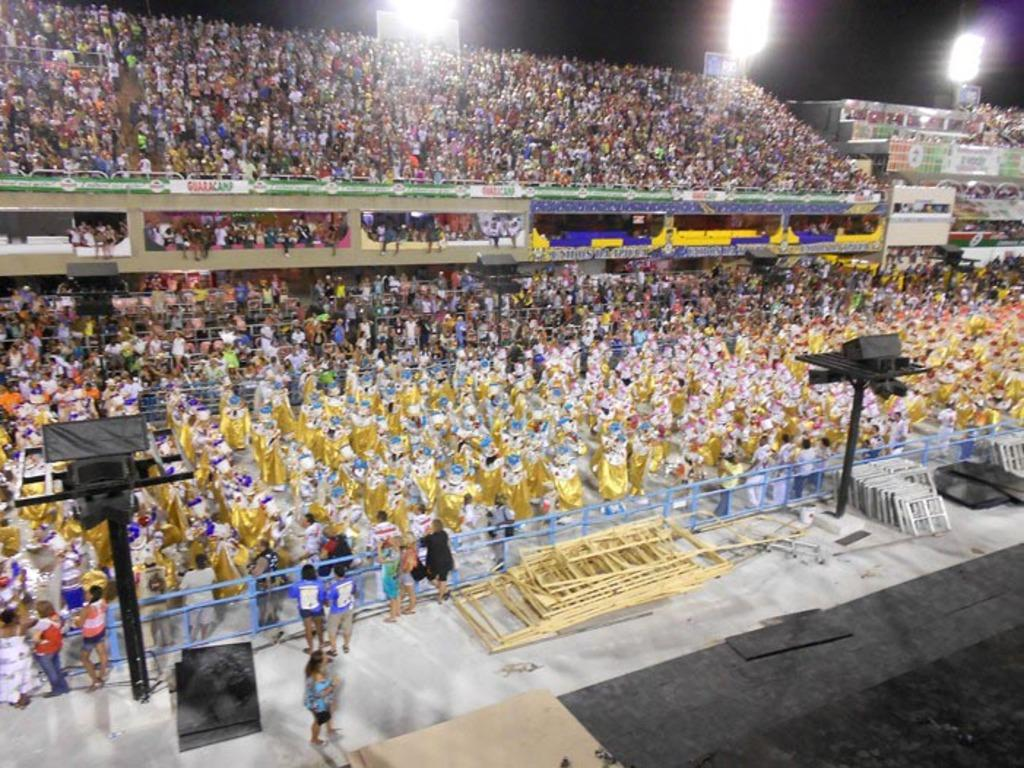What type of venue is depicted in the image? The image is of a stadium. What can be found in the stadium? There are stands, lights, railings, banners, boards, a crowd, and wooden pallets on the floor of the stadium. What might be used to provide support or guidance in the stadium? The railings in the stands can be used for support or guidance in the stadium. What might be used to display information or advertisements in the stadium? The banners and boards in the stadium can be used to display information or advertisements. Can you see a giraffe or a tiger in the image? No, there are no giraffes or tigers present in the image. Where might you find a mailbox in the image? There is no mailbox present in the image. 